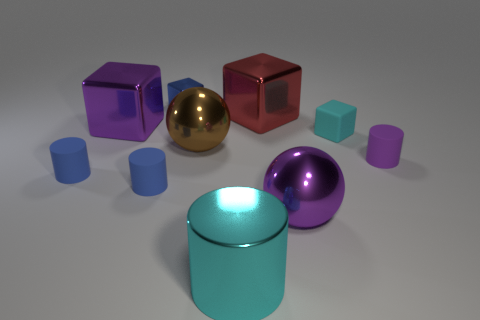Is there a big metal thing of the same color as the tiny matte block?
Your response must be concise. Yes. Is the number of tiny cyan rubber things that are on the left side of the large purple ball the same as the number of large green rubber spheres?
Your response must be concise. Yes. Do the metallic cylinder and the tiny rubber cube have the same color?
Your answer should be very brief. Yes. There is a metallic object that is both in front of the purple cylinder and left of the big red cube; what size is it?
Give a very brief answer. Large. The cylinder that is the same material as the large red thing is what color?
Your answer should be compact. Cyan. How many blue cylinders are the same material as the cyan block?
Offer a very short reply. 2. Are there an equal number of big cyan metallic objects in front of the metallic cylinder and metal objects on the right side of the brown ball?
Ensure brevity in your answer.  No. Does the large brown thing have the same shape as the purple shiny object right of the cyan metal cylinder?
Give a very brief answer. Yes. There is a object that is the same color as the metallic cylinder; what is its material?
Provide a short and direct response. Rubber. Does the large cyan thing have the same material as the large cube that is on the left side of the blue cube?
Make the answer very short. Yes. 